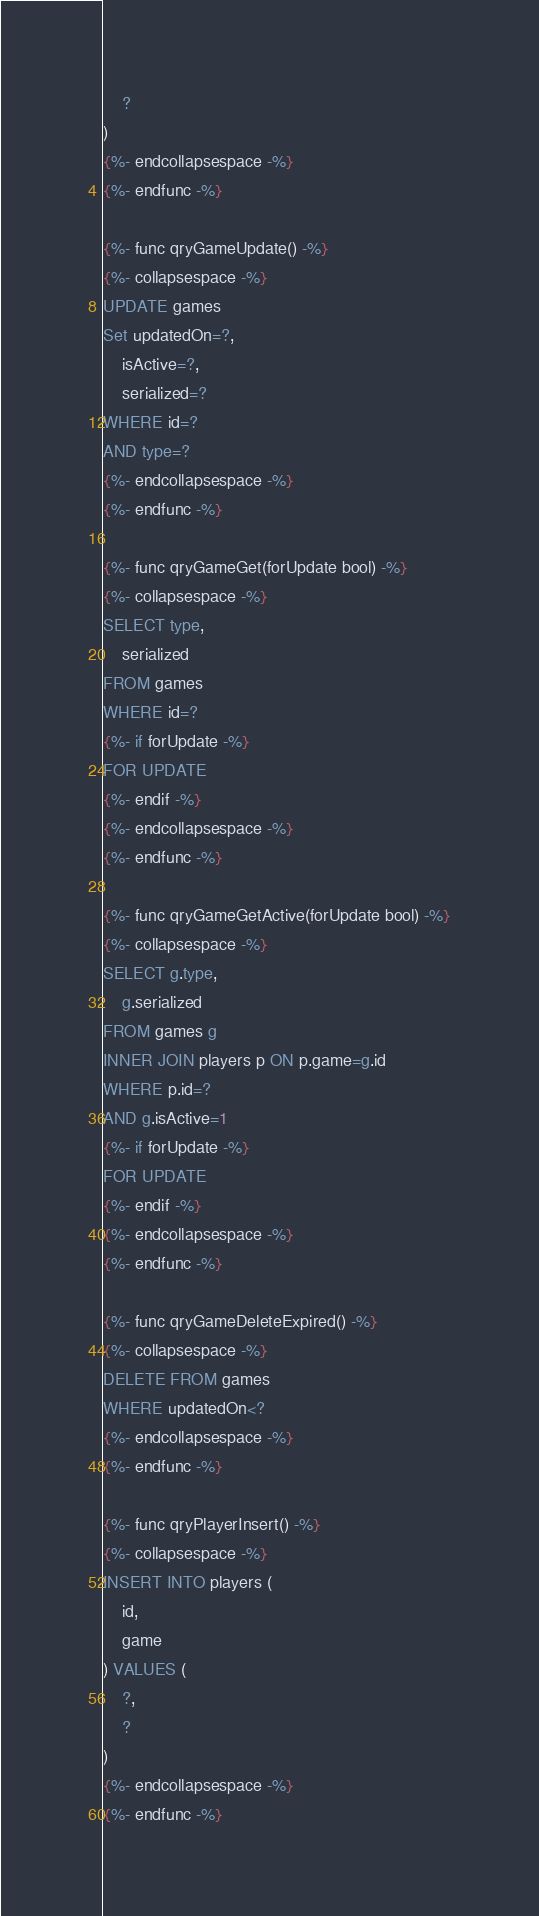<code> <loc_0><loc_0><loc_500><loc_500><_SQL_>    ?
)
{%- endcollapsespace -%}
{%- endfunc -%}

{%- func qryGameUpdate() -%}
{%- collapsespace -%}
UPDATE games
Set updatedOn=?,
    isActive=?,
    serialized=?
WHERE id=?
AND type=?
{%- endcollapsespace -%}
{%- endfunc -%}

{%- func qryGameGet(forUpdate bool) -%}
{%- collapsespace -%}
SELECT type,
    serialized
FROM games
WHERE id=?
{%- if forUpdate -%}
FOR UPDATE
{%- endif -%}
{%- endcollapsespace -%}
{%- endfunc -%}

{%- func qryGameGetActive(forUpdate bool) -%}
{%- collapsespace -%}
SELECT g.type,
    g.serialized
FROM games g
INNER JOIN players p ON p.game=g.id
WHERE p.id=?
AND g.isActive=1
{%- if forUpdate -%}
FOR UPDATE
{%- endif -%}
{%- endcollapsespace -%}
{%- endfunc -%}

{%- func qryGameDeleteExpired() -%}
{%- collapsespace -%}
DELETE FROM games
WHERE updatedOn<?
{%- endcollapsespace -%}
{%- endfunc -%}

{%- func qryPlayerInsert() -%}
{%- collapsespace -%}
INSERT INTO players (
    id,
    game
) VALUES (
    ?,
    ?
)
{%- endcollapsespace -%}
{%- endfunc -%}</code> 